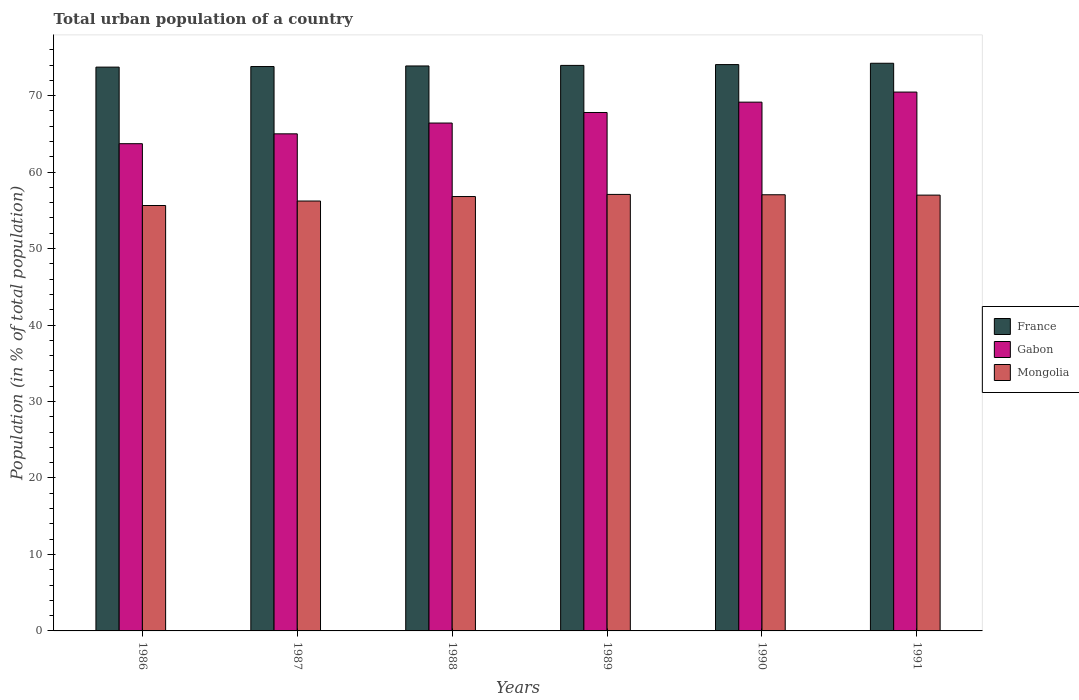How many groups of bars are there?
Your answer should be very brief. 6. Are the number of bars on each tick of the X-axis equal?
Your answer should be very brief. Yes. How many bars are there on the 6th tick from the right?
Provide a succinct answer. 3. What is the label of the 2nd group of bars from the left?
Your response must be concise. 1987. What is the urban population in Mongolia in 1987?
Your response must be concise. 56.22. Across all years, what is the maximum urban population in Mongolia?
Offer a terse response. 57.08. Across all years, what is the minimum urban population in France?
Your response must be concise. 73.72. In which year was the urban population in Mongolia maximum?
Make the answer very short. 1989. What is the total urban population in France in the graph?
Provide a succinct answer. 443.63. What is the difference between the urban population in Mongolia in 1990 and that in 1991?
Give a very brief answer. 0.05. What is the difference between the urban population in France in 1988 and the urban population in Gabon in 1989?
Provide a short and direct response. 6.08. What is the average urban population in France per year?
Make the answer very short. 73.94. In the year 1989, what is the difference between the urban population in Mongolia and urban population in France?
Your answer should be compact. -16.87. What is the ratio of the urban population in Gabon in 1990 to that in 1991?
Ensure brevity in your answer.  0.98. Is the urban population in Mongolia in 1988 less than that in 1990?
Provide a short and direct response. Yes. Is the difference between the urban population in Mongolia in 1989 and 1990 greater than the difference between the urban population in France in 1989 and 1990?
Your answer should be compact. Yes. What is the difference between the highest and the second highest urban population in Mongolia?
Your answer should be very brief. 0.05. What is the difference between the highest and the lowest urban population in Mongolia?
Your response must be concise. 1.45. What does the 3rd bar from the left in 1990 represents?
Offer a very short reply. Mongolia. What does the 1st bar from the right in 1990 represents?
Keep it short and to the point. Mongolia. Is it the case that in every year, the sum of the urban population in France and urban population in Gabon is greater than the urban population in Mongolia?
Offer a terse response. Yes. How many bars are there?
Provide a short and direct response. 18. What is the difference between two consecutive major ticks on the Y-axis?
Offer a very short reply. 10. Are the values on the major ticks of Y-axis written in scientific E-notation?
Keep it short and to the point. No. Does the graph contain any zero values?
Offer a very short reply. No. Does the graph contain grids?
Ensure brevity in your answer.  No. Where does the legend appear in the graph?
Give a very brief answer. Center right. How many legend labels are there?
Keep it short and to the point. 3. What is the title of the graph?
Keep it short and to the point. Total urban population of a country. What is the label or title of the X-axis?
Your answer should be very brief. Years. What is the label or title of the Y-axis?
Offer a terse response. Population (in % of total population). What is the Population (in % of total population) of France in 1986?
Give a very brief answer. 73.72. What is the Population (in % of total population) of Gabon in 1986?
Keep it short and to the point. 63.71. What is the Population (in % of total population) in Mongolia in 1986?
Give a very brief answer. 55.63. What is the Population (in % of total population) of France in 1987?
Provide a short and direct response. 73.8. What is the Population (in % of total population) of Mongolia in 1987?
Offer a very short reply. 56.22. What is the Population (in % of total population) of France in 1988?
Your answer should be very brief. 73.88. What is the Population (in % of total population) of Gabon in 1988?
Your answer should be compact. 66.41. What is the Population (in % of total population) of Mongolia in 1988?
Provide a short and direct response. 56.8. What is the Population (in % of total population) of France in 1989?
Your response must be concise. 73.95. What is the Population (in % of total population) in Gabon in 1989?
Keep it short and to the point. 67.79. What is the Population (in % of total population) of Mongolia in 1989?
Give a very brief answer. 57.08. What is the Population (in % of total population) in France in 1990?
Give a very brief answer. 74.06. What is the Population (in % of total population) in Gabon in 1990?
Keep it short and to the point. 69.14. What is the Population (in % of total population) of Mongolia in 1990?
Your response must be concise. 57.03. What is the Population (in % of total population) in France in 1991?
Offer a terse response. 74.23. What is the Population (in % of total population) of Gabon in 1991?
Provide a succinct answer. 70.46. What is the Population (in % of total population) in Mongolia in 1991?
Offer a very short reply. 56.99. Across all years, what is the maximum Population (in % of total population) in France?
Keep it short and to the point. 74.23. Across all years, what is the maximum Population (in % of total population) in Gabon?
Your answer should be compact. 70.46. Across all years, what is the maximum Population (in % of total population) of Mongolia?
Provide a succinct answer. 57.08. Across all years, what is the minimum Population (in % of total population) in France?
Provide a short and direct response. 73.72. Across all years, what is the minimum Population (in % of total population) of Gabon?
Make the answer very short. 63.71. Across all years, what is the minimum Population (in % of total population) in Mongolia?
Make the answer very short. 55.63. What is the total Population (in % of total population) of France in the graph?
Keep it short and to the point. 443.63. What is the total Population (in % of total population) in Gabon in the graph?
Ensure brevity in your answer.  402.52. What is the total Population (in % of total population) of Mongolia in the graph?
Make the answer very short. 339.74. What is the difference between the Population (in % of total population) in France in 1986 and that in 1987?
Provide a succinct answer. -0.07. What is the difference between the Population (in % of total population) in Gabon in 1986 and that in 1987?
Make the answer very short. -1.29. What is the difference between the Population (in % of total population) in Mongolia in 1986 and that in 1987?
Offer a very short reply. -0.59. What is the difference between the Population (in % of total population) in Gabon in 1986 and that in 1988?
Keep it short and to the point. -2.7. What is the difference between the Population (in % of total population) in Mongolia in 1986 and that in 1988?
Keep it short and to the point. -1.17. What is the difference between the Population (in % of total population) of France in 1986 and that in 1989?
Provide a short and direct response. -0.23. What is the difference between the Population (in % of total population) in Gabon in 1986 and that in 1989?
Ensure brevity in your answer.  -4.08. What is the difference between the Population (in % of total population) in Mongolia in 1986 and that in 1989?
Your response must be concise. -1.45. What is the difference between the Population (in % of total population) in France in 1986 and that in 1990?
Your response must be concise. -0.33. What is the difference between the Population (in % of total population) in Gabon in 1986 and that in 1990?
Ensure brevity in your answer.  -5.43. What is the difference between the Population (in % of total population) of Mongolia in 1986 and that in 1990?
Provide a succinct answer. -1.41. What is the difference between the Population (in % of total population) of France in 1986 and that in 1991?
Provide a succinct answer. -0.5. What is the difference between the Population (in % of total population) of Gabon in 1986 and that in 1991?
Your answer should be compact. -6.75. What is the difference between the Population (in % of total population) of Mongolia in 1986 and that in 1991?
Your answer should be very brief. -1.36. What is the difference between the Population (in % of total population) of France in 1987 and that in 1988?
Provide a short and direct response. -0.07. What is the difference between the Population (in % of total population) of Gabon in 1987 and that in 1988?
Your answer should be very brief. -1.41. What is the difference between the Population (in % of total population) of Mongolia in 1987 and that in 1988?
Your response must be concise. -0.58. What is the difference between the Population (in % of total population) of France in 1987 and that in 1989?
Provide a short and direct response. -0.15. What is the difference between the Population (in % of total population) in Gabon in 1987 and that in 1989?
Your answer should be compact. -2.79. What is the difference between the Population (in % of total population) of Mongolia in 1987 and that in 1989?
Your response must be concise. -0.86. What is the difference between the Population (in % of total population) of France in 1987 and that in 1990?
Your answer should be very brief. -0.26. What is the difference between the Population (in % of total population) in Gabon in 1987 and that in 1990?
Ensure brevity in your answer.  -4.14. What is the difference between the Population (in % of total population) in Mongolia in 1987 and that in 1990?
Ensure brevity in your answer.  -0.82. What is the difference between the Population (in % of total population) in France in 1987 and that in 1991?
Ensure brevity in your answer.  -0.43. What is the difference between the Population (in % of total population) of Gabon in 1987 and that in 1991?
Ensure brevity in your answer.  -5.46. What is the difference between the Population (in % of total population) in Mongolia in 1987 and that in 1991?
Your response must be concise. -0.77. What is the difference between the Population (in % of total population) of France in 1988 and that in 1989?
Your answer should be compact. -0.07. What is the difference between the Population (in % of total population) of Gabon in 1988 and that in 1989?
Offer a terse response. -1.38. What is the difference between the Population (in % of total population) of Mongolia in 1988 and that in 1989?
Offer a very short reply. -0.28. What is the difference between the Population (in % of total population) of France in 1988 and that in 1990?
Keep it short and to the point. -0.18. What is the difference between the Population (in % of total population) of Gabon in 1988 and that in 1990?
Make the answer very short. -2.73. What is the difference between the Population (in % of total population) of Mongolia in 1988 and that in 1990?
Offer a very short reply. -0.23. What is the difference between the Population (in % of total population) of France in 1988 and that in 1991?
Provide a short and direct response. -0.35. What is the difference between the Population (in % of total population) in Gabon in 1988 and that in 1991?
Your response must be concise. -4.05. What is the difference between the Population (in % of total population) in Mongolia in 1988 and that in 1991?
Ensure brevity in your answer.  -0.19. What is the difference between the Population (in % of total population) of France in 1989 and that in 1990?
Keep it short and to the point. -0.11. What is the difference between the Population (in % of total population) of Gabon in 1989 and that in 1990?
Make the answer very short. -1.35. What is the difference between the Population (in % of total population) in Mongolia in 1989 and that in 1990?
Offer a terse response. 0.04. What is the difference between the Population (in % of total population) of France in 1989 and that in 1991?
Your answer should be very brief. -0.28. What is the difference between the Population (in % of total population) of Gabon in 1989 and that in 1991?
Keep it short and to the point. -2.67. What is the difference between the Population (in % of total population) of Mongolia in 1989 and that in 1991?
Your answer should be compact. 0.09. What is the difference between the Population (in % of total population) in France in 1990 and that in 1991?
Offer a very short reply. -0.17. What is the difference between the Population (in % of total population) of Gabon in 1990 and that in 1991?
Provide a short and direct response. -1.32. What is the difference between the Population (in % of total population) in Mongolia in 1990 and that in 1991?
Ensure brevity in your answer.  0.05. What is the difference between the Population (in % of total population) in France in 1986 and the Population (in % of total population) in Gabon in 1987?
Make the answer very short. 8.72. What is the difference between the Population (in % of total population) of France in 1986 and the Population (in % of total population) of Mongolia in 1987?
Keep it short and to the point. 17.51. What is the difference between the Population (in % of total population) in Gabon in 1986 and the Population (in % of total population) in Mongolia in 1987?
Your answer should be very brief. 7.5. What is the difference between the Population (in % of total population) in France in 1986 and the Population (in % of total population) in Gabon in 1988?
Your answer should be very brief. 7.31. What is the difference between the Population (in % of total population) in France in 1986 and the Population (in % of total population) in Mongolia in 1988?
Offer a very short reply. 16.93. What is the difference between the Population (in % of total population) of Gabon in 1986 and the Population (in % of total population) of Mongolia in 1988?
Provide a succinct answer. 6.91. What is the difference between the Population (in % of total population) of France in 1986 and the Population (in % of total population) of Gabon in 1989?
Offer a terse response. 5.93. What is the difference between the Population (in % of total population) of France in 1986 and the Population (in % of total population) of Mongolia in 1989?
Provide a succinct answer. 16.65. What is the difference between the Population (in % of total population) of Gabon in 1986 and the Population (in % of total population) of Mongolia in 1989?
Your answer should be compact. 6.63. What is the difference between the Population (in % of total population) in France in 1986 and the Population (in % of total population) in Gabon in 1990?
Your answer should be very brief. 4.58. What is the difference between the Population (in % of total population) in France in 1986 and the Population (in % of total population) in Mongolia in 1990?
Provide a short and direct response. 16.69. What is the difference between the Population (in % of total population) in Gabon in 1986 and the Population (in % of total population) in Mongolia in 1990?
Keep it short and to the point. 6.68. What is the difference between the Population (in % of total population) in France in 1986 and the Population (in % of total population) in Gabon in 1991?
Offer a very short reply. 3.26. What is the difference between the Population (in % of total population) in France in 1986 and the Population (in % of total population) in Mongolia in 1991?
Make the answer very short. 16.74. What is the difference between the Population (in % of total population) in Gabon in 1986 and the Population (in % of total population) in Mongolia in 1991?
Keep it short and to the point. 6.72. What is the difference between the Population (in % of total population) in France in 1987 and the Population (in % of total population) in Gabon in 1988?
Ensure brevity in your answer.  7.39. What is the difference between the Population (in % of total population) in France in 1987 and the Population (in % of total population) in Mongolia in 1988?
Provide a succinct answer. 17. What is the difference between the Population (in % of total population) of Gabon in 1987 and the Population (in % of total population) of Mongolia in 1988?
Offer a terse response. 8.2. What is the difference between the Population (in % of total population) in France in 1987 and the Population (in % of total population) in Gabon in 1989?
Offer a terse response. 6.01. What is the difference between the Population (in % of total population) of France in 1987 and the Population (in % of total population) of Mongolia in 1989?
Ensure brevity in your answer.  16.72. What is the difference between the Population (in % of total population) in Gabon in 1987 and the Population (in % of total population) in Mongolia in 1989?
Ensure brevity in your answer.  7.92. What is the difference between the Population (in % of total population) in France in 1987 and the Population (in % of total population) in Gabon in 1990?
Your answer should be very brief. 4.66. What is the difference between the Population (in % of total population) in France in 1987 and the Population (in % of total population) in Mongolia in 1990?
Offer a terse response. 16.77. What is the difference between the Population (in % of total population) in Gabon in 1987 and the Population (in % of total population) in Mongolia in 1990?
Keep it short and to the point. 7.97. What is the difference between the Population (in % of total population) of France in 1987 and the Population (in % of total population) of Gabon in 1991?
Offer a terse response. 3.34. What is the difference between the Population (in % of total population) of France in 1987 and the Population (in % of total population) of Mongolia in 1991?
Provide a short and direct response. 16.81. What is the difference between the Population (in % of total population) in Gabon in 1987 and the Population (in % of total population) in Mongolia in 1991?
Provide a succinct answer. 8.01. What is the difference between the Population (in % of total population) in France in 1988 and the Population (in % of total population) in Gabon in 1989?
Keep it short and to the point. 6.08. What is the difference between the Population (in % of total population) in France in 1988 and the Population (in % of total population) in Mongolia in 1989?
Keep it short and to the point. 16.8. What is the difference between the Population (in % of total population) in Gabon in 1988 and the Population (in % of total population) in Mongolia in 1989?
Provide a short and direct response. 9.33. What is the difference between the Population (in % of total population) of France in 1988 and the Population (in % of total population) of Gabon in 1990?
Provide a succinct answer. 4.73. What is the difference between the Population (in % of total population) in France in 1988 and the Population (in % of total population) in Mongolia in 1990?
Keep it short and to the point. 16.84. What is the difference between the Population (in % of total population) of Gabon in 1988 and the Population (in % of total population) of Mongolia in 1990?
Ensure brevity in your answer.  9.38. What is the difference between the Population (in % of total population) in France in 1988 and the Population (in % of total population) in Gabon in 1991?
Ensure brevity in your answer.  3.41. What is the difference between the Population (in % of total population) in France in 1988 and the Population (in % of total population) in Mongolia in 1991?
Your answer should be very brief. 16.89. What is the difference between the Population (in % of total population) in Gabon in 1988 and the Population (in % of total population) in Mongolia in 1991?
Offer a very short reply. 9.43. What is the difference between the Population (in % of total population) in France in 1989 and the Population (in % of total population) in Gabon in 1990?
Your answer should be compact. 4.81. What is the difference between the Population (in % of total population) of France in 1989 and the Population (in % of total population) of Mongolia in 1990?
Make the answer very short. 16.92. What is the difference between the Population (in % of total population) of Gabon in 1989 and the Population (in % of total population) of Mongolia in 1990?
Offer a very short reply. 10.76. What is the difference between the Population (in % of total population) in France in 1989 and the Population (in % of total population) in Gabon in 1991?
Your response must be concise. 3.49. What is the difference between the Population (in % of total population) in France in 1989 and the Population (in % of total population) in Mongolia in 1991?
Your response must be concise. 16.96. What is the difference between the Population (in % of total population) of Gabon in 1989 and the Population (in % of total population) of Mongolia in 1991?
Offer a very short reply. 10.8. What is the difference between the Population (in % of total population) of France in 1990 and the Population (in % of total population) of Gabon in 1991?
Provide a short and direct response. 3.59. What is the difference between the Population (in % of total population) of France in 1990 and the Population (in % of total population) of Mongolia in 1991?
Your response must be concise. 17.07. What is the difference between the Population (in % of total population) in Gabon in 1990 and the Population (in % of total population) in Mongolia in 1991?
Keep it short and to the point. 12.16. What is the average Population (in % of total population) in France per year?
Keep it short and to the point. 73.94. What is the average Population (in % of total population) of Gabon per year?
Your answer should be very brief. 67.09. What is the average Population (in % of total population) in Mongolia per year?
Your answer should be very brief. 56.62. In the year 1986, what is the difference between the Population (in % of total population) of France and Population (in % of total population) of Gabon?
Your answer should be compact. 10.01. In the year 1986, what is the difference between the Population (in % of total population) of France and Population (in % of total population) of Mongolia?
Offer a very short reply. 18.1. In the year 1986, what is the difference between the Population (in % of total population) in Gabon and Population (in % of total population) in Mongolia?
Your response must be concise. 8.08. In the year 1987, what is the difference between the Population (in % of total population) of France and Population (in % of total population) of Mongolia?
Your answer should be compact. 17.59. In the year 1987, what is the difference between the Population (in % of total population) of Gabon and Population (in % of total population) of Mongolia?
Keep it short and to the point. 8.79. In the year 1988, what is the difference between the Population (in % of total population) in France and Population (in % of total population) in Gabon?
Give a very brief answer. 7.46. In the year 1988, what is the difference between the Population (in % of total population) in France and Population (in % of total population) in Mongolia?
Keep it short and to the point. 17.07. In the year 1988, what is the difference between the Population (in % of total population) in Gabon and Population (in % of total population) in Mongolia?
Your response must be concise. 9.61. In the year 1989, what is the difference between the Population (in % of total population) in France and Population (in % of total population) in Gabon?
Provide a short and direct response. 6.16. In the year 1989, what is the difference between the Population (in % of total population) of France and Population (in % of total population) of Mongolia?
Make the answer very short. 16.87. In the year 1989, what is the difference between the Population (in % of total population) of Gabon and Population (in % of total population) of Mongolia?
Your response must be concise. 10.71. In the year 1990, what is the difference between the Population (in % of total population) in France and Population (in % of total population) in Gabon?
Your response must be concise. 4.91. In the year 1990, what is the difference between the Population (in % of total population) of France and Population (in % of total population) of Mongolia?
Make the answer very short. 17.02. In the year 1990, what is the difference between the Population (in % of total population) of Gabon and Population (in % of total population) of Mongolia?
Offer a very short reply. 12.11. In the year 1991, what is the difference between the Population (in % of total population) in France and Population (in % of total population) in Gabon?
Provide a succinct answer. 3.77. In the year 1991, what is the difference between the Population (in % of total population) of France and Population (in % of total population) of Mongolia?
Your answer should be very brief. 17.24. In the year 1991, what is the difference between the Population (in % of total population) in Gabon and Population (in % of total population) in Mongolia?
Your answer should be very brief. 13.47. What is the ratio of the Population (in % of total population) in France in 1986 to that in 1987?
Ensure brevity in your answer.  1. What is the ratio of the Population (in % of total population) in Gabon in 1986 to that in 1987?
Ensure brevity in your answer.  0.98. What is the ratio of the Population (in % of total population) in Mongolia in 1986 to that in 1987?
Offer a terse response. 0.99. What is the ratio of the Population (in % of total population) of Gabon in 1986 to that in 1988?
Make the answer very short. 0.96. What is the ratio of the Population (in % of total population) in Mongolia in 1986 to that in 1988?
Your answer should be compact. 0.98. What is the ratio of the Population (in % of total population) of France in 1986 to that in 1989?
Provide a short and direct response. 1. What is the ratio of the Population (in % of total population) in Gabon in 1986 to that in 1989?
Your answer should be very brief. 0.94. What is the ratio of the Population (in % of total population) in Mongolia in 1986 to that in 1989?
Offer a very short reply. 0.97. What is the ratio of the Population (in % of total population) of Gabon in 1986 to that in 1990?
Provide a short and direct response. 0.92. What is the ratio of the Population (in % of total population) in Mongolia in 1986 to that in 1990?
Your response must be concise. 0.98. What is the ratio of the Population (in % of total population) in France in 1986 to that in 1991?
Offer a very short reply. 0.99. What is the ratio of the Population (in % of total population) of Gabon in 1986 to that in 1991?
Give a very brief answer. 0.9. What is the ratio of the Population (in % of total population) in Mongolia in 1986 to that in 1991?
Your response must be concise. 0.98. What is the ratio of the Population (in % of total population) of Gabon in 1987 to that in 1988?
Keep it short and to the point. 0.98. What is the ratio of the Population (in % of total population) of France in 1987 to that in 1989?
Your answer should be compact. 1. What is the ratio of the Population (in % of total population) of Gabon in 1987 to that in 1989?
Provide a short and direct response. 0.96. What is the ratio of the Population (in % of total population) of Mongolia in 1987 to that in 1989?
Offer a very short reply. 0.98. What is the ratio of the Population (in % of total population) in France in 1987 to that in 1990?
Offer a very short reply. 1. What is the ratio of the Population (in % of total population) of Gabon in 1987 to that in 1990?
Give a very brief answer. 0.94. What is the ratio of the Population (in % of total population) in Mongolia in 1987 to that in 1990?
Offer a terse response. 0.99. What is the ratio of the Population (in % of total population) in France in 1987 to that in 1991?
Provide a short and direct response. 0.99. What is the ratio of the Population (in % of total population) of Gabon in 1987 to that in 1991?
Make the answer very short. 0.92. What is the ratio of the Population (in % of total population) of Mongolia in 1987 to that in 1991?
Offer a very short reply. 0.99. What is the ratio of the Population (in % of total population) of Gabon in 1988 to that in 1989?
Offer a very short reply. 0.98. What is the ratio of the Population (in % of total population) of France in 1988 to that in 1990?
Your answer should be compact. 1. What is the ratio of the Population (in % of total population) of Gabon in 1988 to that in 1990?
Your answer should be very brief. 0.96. What is the ratio of the Population (in % of total population) of France in 1988 to that in 1991?
Offer a very short reply. 1. What is the ratio of the Population (in % of total population) in Gabon in 1988 to that in 1991?
Offer a terse response. 0.94. What is the ratio of the Population (in % of total population) of Gabon in 1989 to that in 1990?
Ensure brevity in your answer.  0.98. What is the ratio of the Population (in % of total population) of Mongolia in 1989 to that in 1990?
Provide a succinct answer. 1. What is the ratio of the Population (in % of total population) in Gabon in 1989 to that in 1991?
Provide a short and direct response. 0.96. What is the ratio of the Population (in % of total population) in Mongolia in 1989 to that in 1991?
Offer a terse response. 1. What is the ratio of the Population (in % of total population) of France in 1990 to that in 1991?
Your answer should be compact. 1. What is the ratio of the Population (in % of total population) in Gabon in 1990 to that in 1991?
Ensure brevity in your answer.  0.98. What is the ratio of the Population (in % of total population) in Mongolia in 1990 to that in 1991?
Offer a very short reply. 1. What is the difference between the highest and the second highest Population (in % of total population) of France?
Your answer should be compact. 0.17. What is the difference between the highest and the second highest Population (in % of total population) of Gabon?
Provide a succinct answer. 1.32. What is the difference between the highest and the second highest Population (in % of total population) of Mongolia?
Give a very brief answer. 0.04. What is the difference between the highest and the lowest Population (in % of total population) of France?
Offer a very short reply. 0.5. What is the difference between the highest and the lowest Population (in % of total population) in Gabon?
Give a very brief answer. 6.75. What is the difference between the highest and the lowest Population (in % of total population) in Mongolia?
Give a very brief answer. 1.45. 